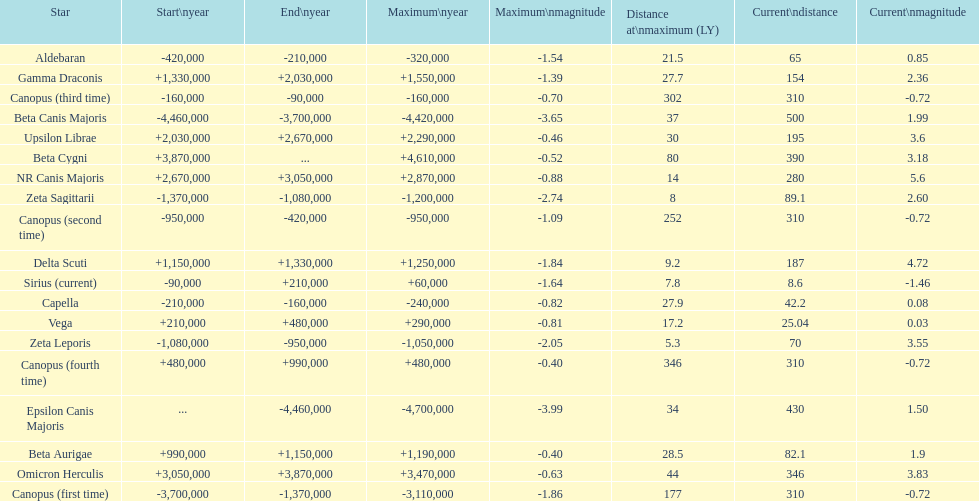How much farther (in ly) is epsilon canis majoris than zeta sagittarii? 26. 